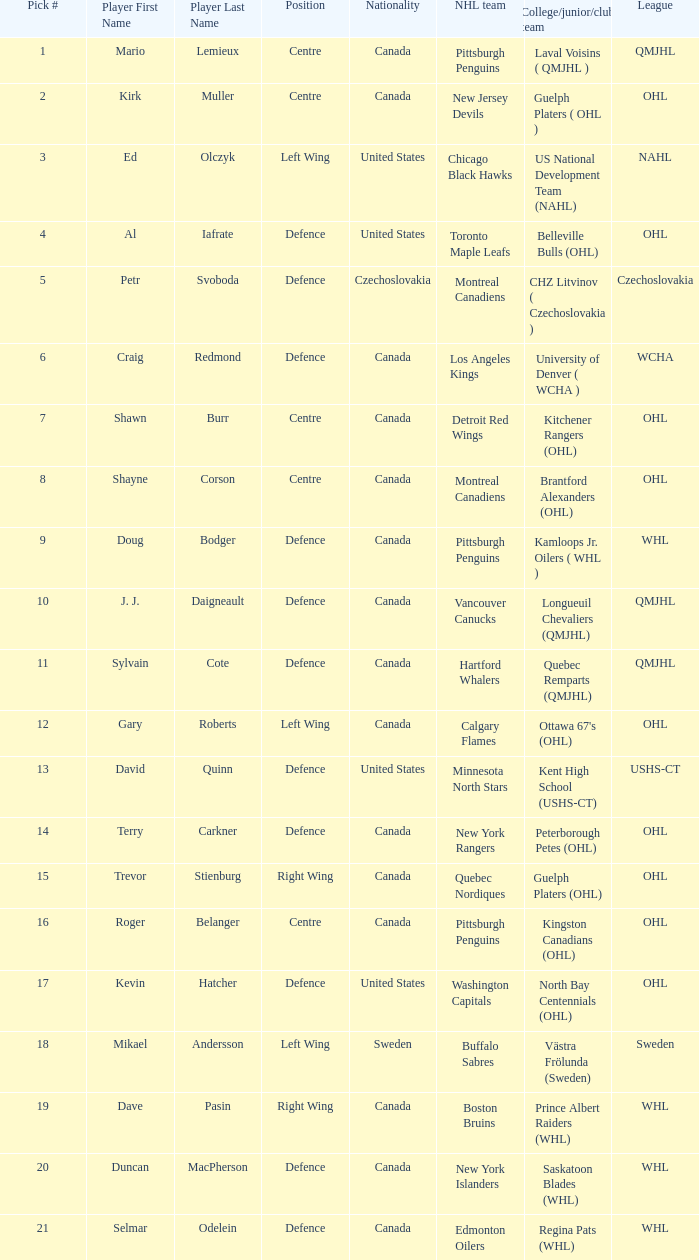What college team did draft pick 18 come from? Västra Frölunda (Sweden). 